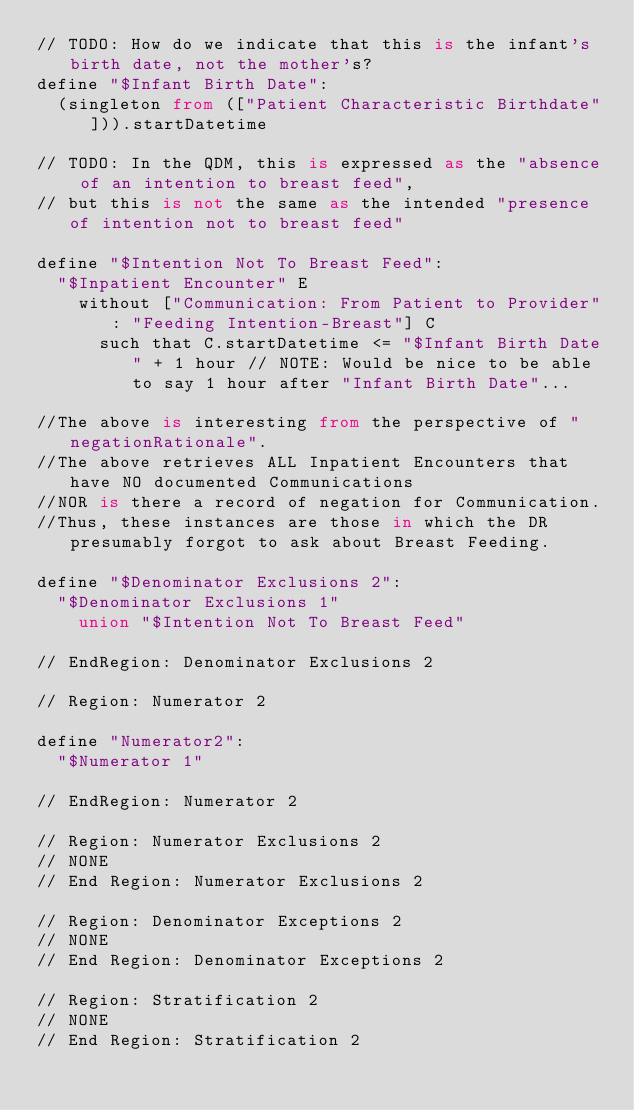<code> <loc_0><loc_0><loc_500><loc_500><_SQL_>// TODO: How do we indicate that this is the infant's birth date, not the mother's?
define "$Infant Birth Date":
  (singleton from (["Patient Characteristic Birthdate"])).startDatetime

// TODO: In the QDM, this is expressed as the "absence of an intention to breast feed",
// but this is not the same as the intended "presence of intention not to breast feed"

define "$Intention Not To Breast Feed":
  "$Inpatient Encounter" E
    without ["Communication: From Patient to Provider": "Feeding Intention-Breast"] C
      such that C.startDatetime <= "$Infant Birth Date" + 1 hour // NOTE: Would be nice to be able to say 1 hour after "Infant Birth Date"...

//The above is interesting from the perspective of "negationRationale".
//The above retrieves ALL Inpatient Encounters that have NO documented Communications
//NOR is there a record of negation for Communication.
//Thus, these instances are those in which the DR presumably forgot to ask about Breast Feeding.

define "$Denominator Exclusions 2":
  "$Denominator Exclusions 1"
    union "$Intention Not To Breast Feed"

// EndRegion: Denominator Exclusions 2

// Region: Numerator 2

define "Numerator2":
  "$Numerator 1"

// EndRegion: Numerator 2

// Region: Numerator Exclusions 2
// NONE
// End Region: Numerator Exclusions 2

// Region: Denominator Exceptions 2
// NONE
// End Region: Denominator Exceptions 2

// Region: Stratification 2
// NONE
// End Region: Stratification 2

</code> 